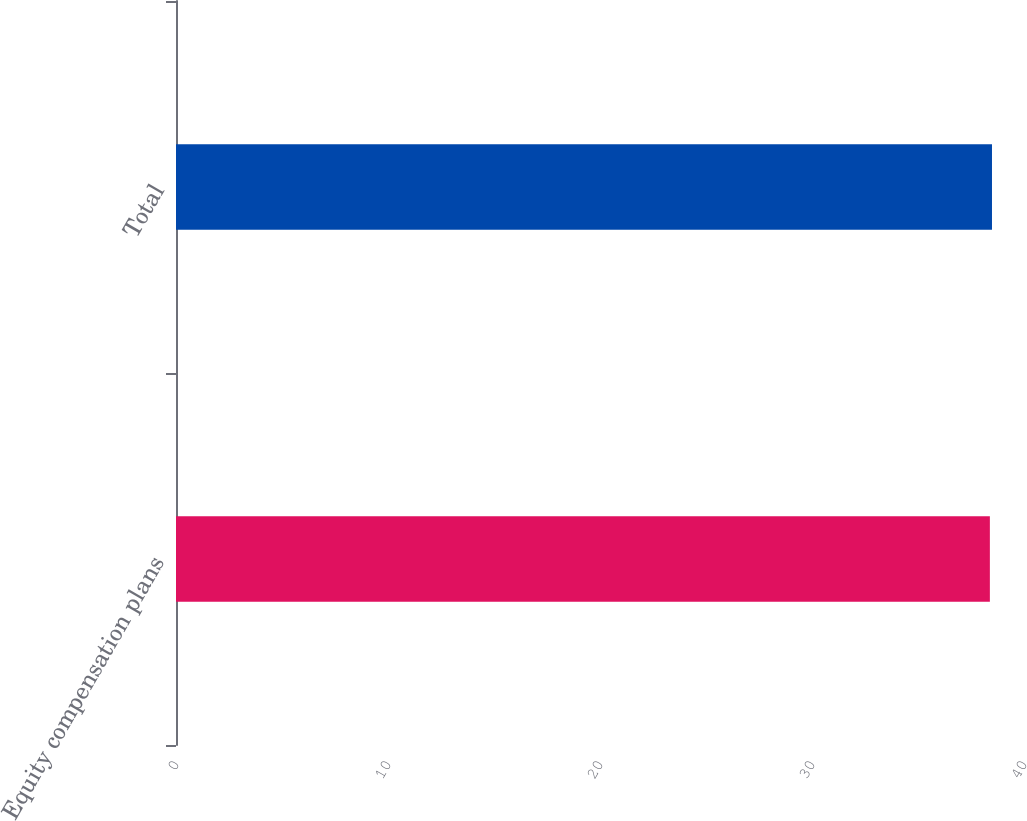<chart> <loc_0><loc_0><loc_500><loc_500><bar_chart><fcel>Equity compensation plans<fcel>Total<nl><fcel>38.39<fcel>38.49<nl></chart> 